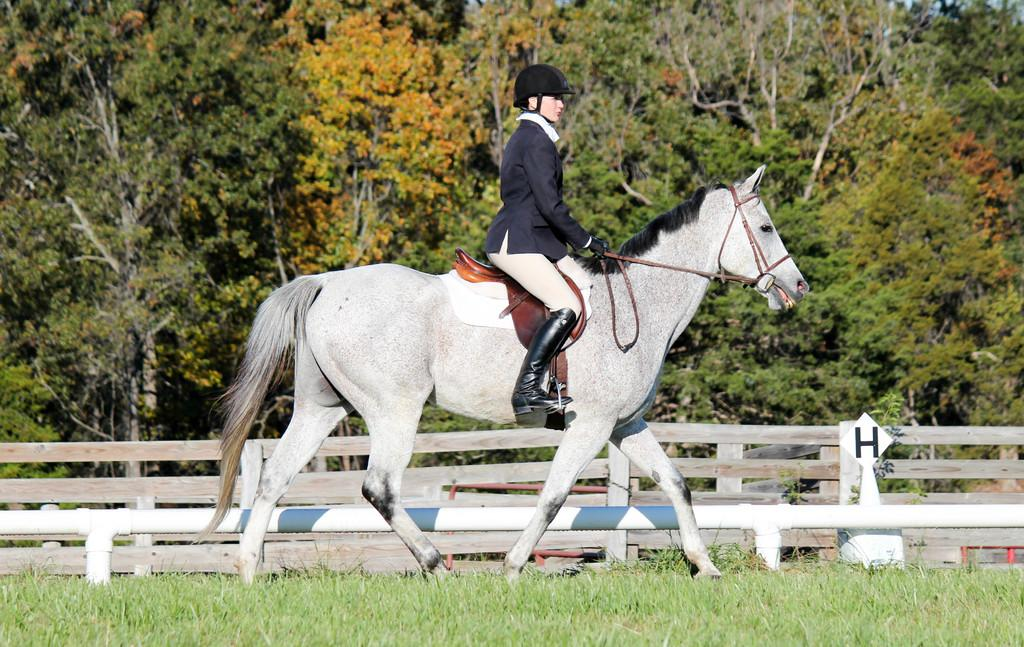Who is the main subject in the image? There is a woman in the image. What is the woman doing in the image? The woman is sitting on a horse and riding it. Where is the woman and the horse located? The horse and the woman are on the ground. What can be seen in the background of the image? There are trees near the woman. Can you see any mice swinging in space in the image? No, there are no mice or any space-related elements present in the image. 